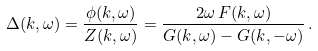Convert formula to latex. <formula><loc_0><loc_0><loc_500><loc_500>\Delta ( k , \omega ) = \frac { \phi ( k , \omega ) } { Z ( k , \omega ) } = \frac { 2 \omega \, F ( k , \omega ) } { G ( k , \omega ) - G ( k , - \omega ) } \, .</formula> 